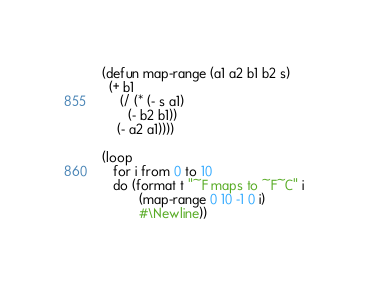<code> <loc_0><loc_0><loc_500><loc_500><_Lisp_>(defun map-range (a1 a2 b1 b2 s)
  (+ b1
     (/ (* (- s a1)
	   (- b2 b1))
	(- a2 a1))))

(loop
   for i from 0 to 10
   do (format t "~F maps to ~F~C" i
	      (map-range 0 10 -1 0 i)
	      #\Newline))
</code> 